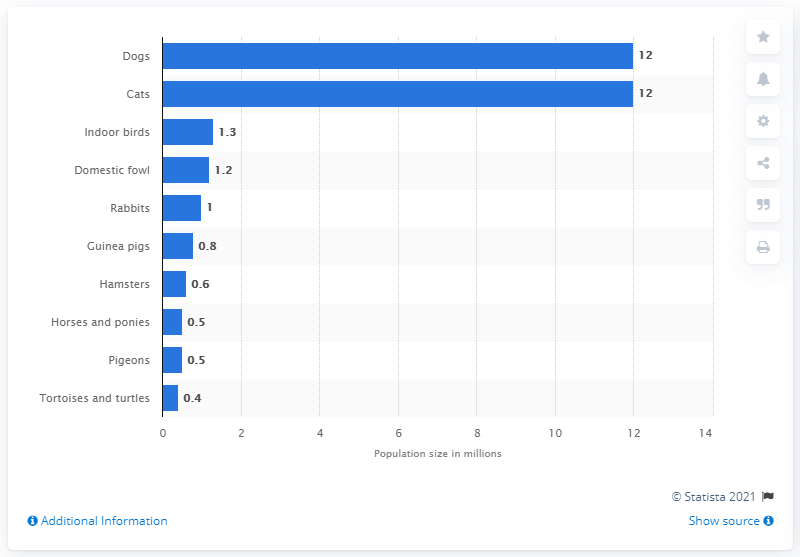Mention a couple of crucial points in this snapshot. In 2021, it is estimated that there were approximately 9.1 million dogs and 12 million cats living in the United Kingdom. In 2021, there were approximately 12 million cats and 67 million dogs in the United Kingdom. 